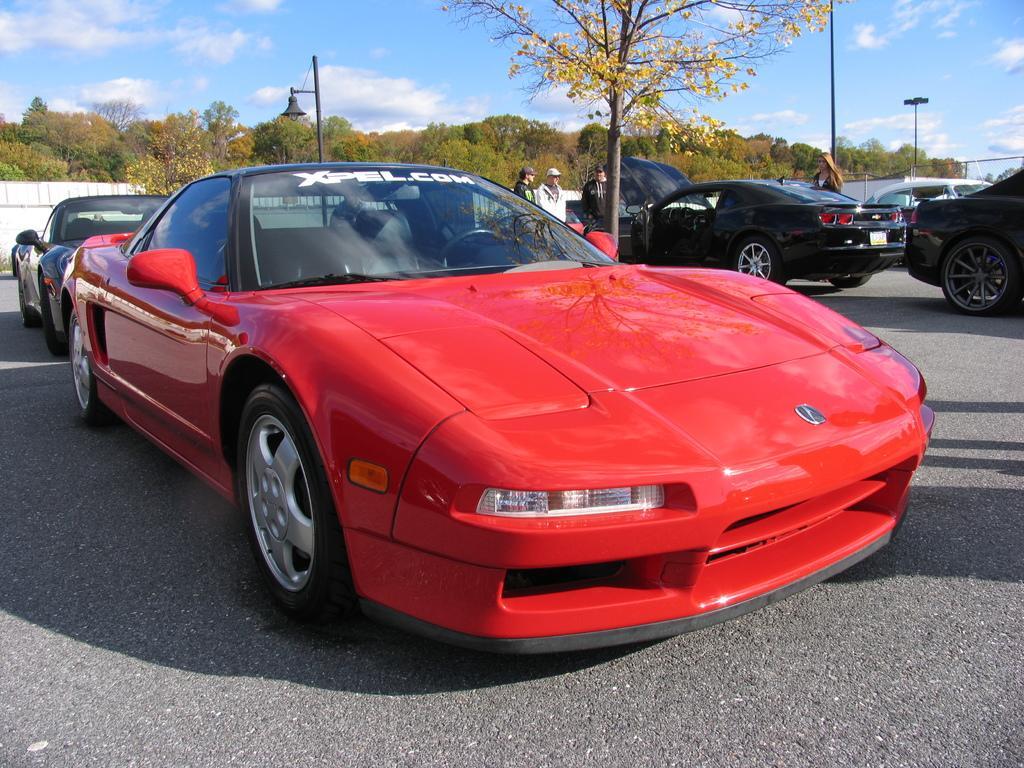Can you describe this image briefly? In this image we can see vehicles and few persons on the road. There are poles, wall, and trees. In the background there is sky with clouds. 